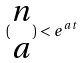<formula> <loc_0><loc_0><loc_500><loc_500>( \begin{matrix} n \\ a \end{matrix} ) < e ^ { a t }</formula> 